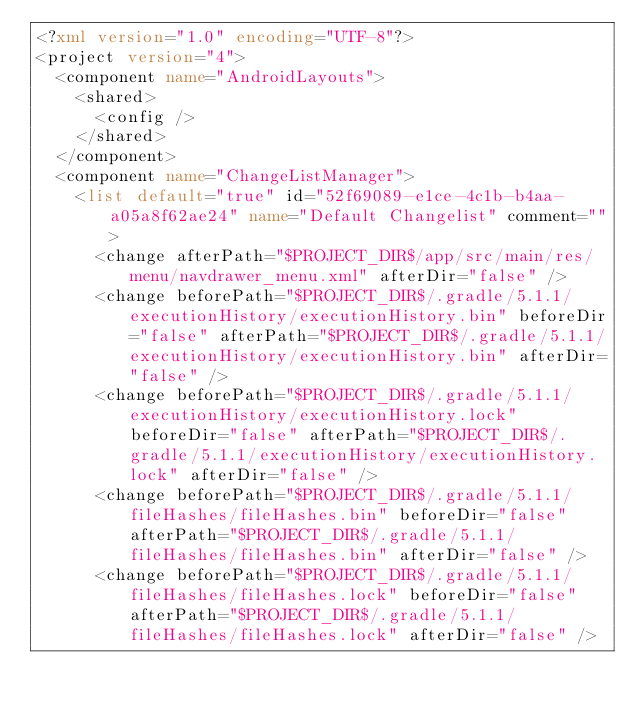<code> <loc_0><loc_0><loc_500><loc_500><_XML_><?xml version="1.0" encoding="UTF-8"?>
<project version="4">
  <component name="AndroidLayouts">
    <shared>
      <config />
    </shared>
  </component>
  <component name="ChangeListManager">
    <list default="true" id="52f69089-e1ce-4c1b-b4aa-a05a8f62ae24" name="Default Changelist" comment="">
      <change afterPath="$PROJECT_DIR$/app/src/main/res/menu/navdrawer_menu.xml" afterDir="false" />
      <change beforePath="$PROJECT_DIR$/.gradle/5.1.1/executionHistory/executionHistory.bin" beforeDir="false" afterPath="$PROJECT_DIR$/.gradle/5.1.1/executionHistory/executionHistory.bin" afterDir="false" />
      <change beforePath="$PROJECT_DIR$/.gradle/5.1.1/executionHistory/executionHistory.lock" beforeDir="false" afterPath="$PROJECT_DIR$/.gradle/5.1.1/executionHistory/executionHistory.lock" afterDir="false" />
      <change beforePath="$PROJECT_DIR$/.gradle/5.1.1/fileHashes/fileHashes.bin" beforeDir="false" afterPath="$PROJECT_DIR$/.gradle/5.1.1/fileHashes/fileHashes.bin" afterDir="false" />
      <change beforePath="$PROJECT_DIR$/.gradle/5.1.1/fileHashes/fileHashes.lock" beforeDir="false" afterPath="$PROJECT_DIR$/.gradle/5.1.1/fileHashes/fileHashes.lock" afterDir="false" /></code> 